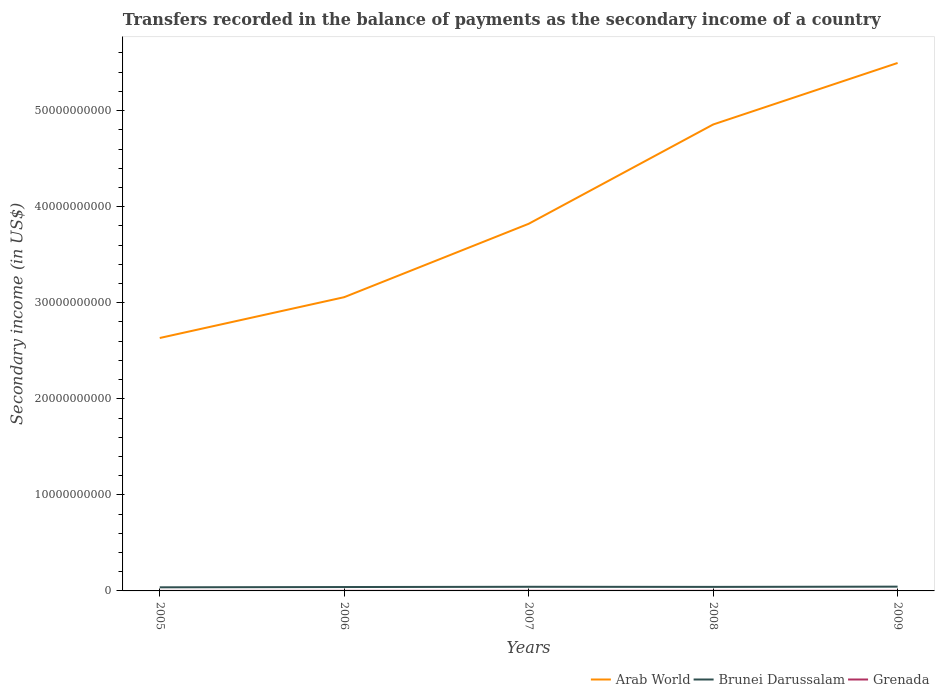How many different coloured lines are there?
Your response must be concise. 3. Is the number of lines equal to the number of legend labels?
Offer a very short reply. Yes. Across all years, what is the maximum secondary income of in Grenada?
Offer a very short reply. 1.42e+06. What is the total secondary income of in Brunei Darussalam in the graph?
Offer a terse response. -6.92e+07. What is the difference between the highest and the second highest secondary income of in Brunei Darussalam?
Provide a short and direct response. 6.92e+07. What is the difference between the highest and the lowest secondary income of in Grenada?
Make the answer very short. 3. How many lines are there?
Make the answer very short. 3. How many legend labels are there?
Give a very brief answer. 3. How are the legend labels stacked?
Ensure brevity in your answer.  Horizontal. What is the title of the graph?
Ensure brevity in your answer.  Transfers recorded in the balance of payments as the secondary income of a country. Does "New Zealand" appear as one of the legend labels in the graph?
Your answer should be very brief. No. What is the label or title of the Y-axis?
Your answer should be very brief. Secondary income (in US$). What is the Secondary income (in US$) in Arab World in 2005?
Offer a very short reply. 2.63e+1. What is the Secondary income (in US$) in Brunei Darussalam in 2005?
Make the answer very short. 3.76e+08. What is the Secondary income (in US$) in Grenada in 2005?
Offer a very short reply. 1.42e+06. What is the Secondary income (in US$) in Arab World in 2006?
Provide a succinct answer. 3.06e+1. What is the Secondary income (in US$) of Brunei Darussalam in 2006?
Make the answer very short. 4.05e+08. What is the Secondary income (in US$) in Grenada in 2006?
Your response must be concise. 8.19e+06. What is the Secondary income (in US$) of Arab World in 2007?
Your answer should be compact. 3.82e+1. What is the Secondary income (in US$) of Brunei Darussalam in 2007?
Offer a terse response. 4.30e+08. What is the Secondary income (in US$) of Grenada in 2007?
Ensure brevity in your answer.  1.13e+07. What is the Secondary income (in US$) of Arab World in 2008?
Give a very brief answer. 4.86e+1. What is the Secondary income (in US$) in Brunei Darussalam in 2008?
Make the answer very short. 4.20e+08. What is the Secondary income (in US$) in Grenada in 2008?
Ensure brevity in your answer.  1.11e+07. What is the Secondary income (in US$) in Arab World in 2009?
Ensure brevity in your answer.  5.50e+1. What is the Secondary income (in US$) in Brunei Darussalam in 2009?
Give a very brief answer. 4.45e+08. What is the Secondary income (in US$) in Grenada in 2009?
Your response must be concise. 1.14e+07. Across all years, what is the maximum Secondary income (in US$) in Arab World?
Provide a succinct answer. 5.50e+1. Across all years, what is the maximum Secondary income (in US$) in Brunei Darussalam?
Offer a very short reply. 4.45e+08. Across all years, what is the maximum Secondary income (in US$) in Grenada?
Your answer should be very brief. 1.14e+07. Across all years, what is the minimum Secondary income (in US$) of Arab World?
Your response must be concise. 2.63e+1. Across all years, what is the minimum Secondary income (in US$) in Brunei Darussalam?
Make the answer very short. 3.76e+08. Across all years, what is the minimum Secondary income (in US$) in Grenada?
Your answer should be very brief. 1.42e+06. What is the total Secondary income (in US$) in Arab World in the graph?
Keep it short and to the point. 1.99e+11. What is the total Secondary income (in US$) of Brunei Darussalam in the graph?
Make the answer very short. 2.08e+09. What is the total Secondary income (in US$) in Grenada in the graph?
Make the answer very short. 4.34e+07. What is the difference between the Secondary income (in US$) of Arab World in 2005 and that in 2006?
Provide a short and direct response. -4.25e+09. What is the difference between the Secondary income (in US$) of Brunei Darussalam in 2005 and that in 2006?
Offer a very short reply. -2.99e+07. What is the difference between the Secondary income (in US$) in Grenada in 2005 and that in 2006?
Give a very brief answer. -6.77e+06. What is the difference between the Secondary income (in US$) in Arab World in 2005 and that in 2007?
Provide a succinct answer. -1.19e+1. What is the difference between the Secondary income (in US$) of Brunei Darussalam in 2005 and that in 2007?
Offer a terse response. -5.47e+07. What is the difference between the Secondary income (in US$) in Grenada in 2005 and that in 2007?
Make the answer very short. -9.89e+06. What is the difference between the Secondary income (in US$) in Arab World in 2005 and that in 2008?
Your answer should be very brief. -2.22e+1. What is the difference between the Secondary income (in US$) of Brunei Darussalam in 2005 and that in 2008?
Make the answer very short. -4.48e+07. What is the difference between the Secondary income (in US$) in Grenada in 2005 and that in 2008?
Offer a terse response. -9.63e+06. What is the difference between the Secondary income (in US$) in Arab World in 2005 and that in 2009?
Offer a very short reply. -2.86e+1. What is the difference between the Secondary income (in US$) of Brunei Darussalam in 2005 and that in 2009?
Provide a succinct answer. -6.92e+07. What is the difference between the Secondary income (in US$) of Grenada in 2005 and that in 2009?
Offer a terse response. -1.00e+07. What is the difference between the Secondary income (in US$) of Arab World in 2006 and that in 2007?
Keep it short and to the point. -7.64e+09. What is the difference between the Secondary income (in US$) in Brunei Darussalam in 2006 and that in 2007?
Offer a terse response. -2.48e+07. What is the difference between the Secondary income (in US$) in Grenada in 2006 and that in 2007?
Make the answer very short. -3.13e+06. What is the difference between the Secondary income (in US$) of Arab World in 2006 and that in 2008?
Offer a very short reply. -1.80e+1. What is the difference between the Secondary income (in US$) of Brunei Darussalam in 2006 and that in 2008?
Keep it short and to the point. -1.49e+07. What is the difference between the Secondary income (in US$) of Grenada in 2006 and that in 2008?
Give a very brief answer. -2.86e+06. What is the difference between the Secondary income (in US$) in Arab World in 2006 and that in 2009?
Provide a short and direct response. -2.44e+1. What is the difference between the Secondary income (in US$) of Brunei Darussalam in 2006 and that in 2009?
Your answer should be very brief. -3.94e+07. What is the difference between the Secondary income (in US$) in Grenada in 2006 and that in 2009?
Provide a short and direct response. -3.25e+06. What is the difference between the Secondary income (in US$) in Arab World in 2007 and that in 2008?
Make the answer very short. -1.03e+1. What is the difference between the Secondary income (in US$) of Brunei Darussalam in 2007 and that in 2008?
Offer a terse response. 9.93e+06. What is the difference between the Secondary income (in US$) of Grenada in 2007 and that in 2008?
Make the answer very short. 2.65e+05. What is the difference between the Secondary income (in US$) of Arab World in 2007 and that in 2009?
Offer a very short reply. -1.67e+1. What is the difference between the Secondary income (in US$) of Brunei Darussalam in 2007 and that in 2009?
Provide a succinct answer. -1.45e+07. What is the difference between the Secondary income (in US$) of Grenada in 2007 and that in 2009?
Offer a terse response. -1.26e+05. What is the difference between the Secondary income (in US$) in Arab World in 2008 and that in 2009?
Give a very brief answer. -6.40e+09. What is the difference between the Secondary income (in US$) in Brunei Darussalam in 2008 and that in 2009?
Give a very brief answer. -2.45e+07. What is the difference between the Secondary income (in US$) of Grenada in 2008 and that in 2009?
Ensure brevity in your answer.  -3.91e+05. What is the difference between the Secondary income (in US$) in Arab World in 2005 and the Secondary income (in US$) in Brunei Darussalam in 2006?
Keep it short and to the point. 2.59e+1. What is the difference between the Secondary income (in US$) of Arab World in 2005 and the Secondary income (in US$) of Grenada in 2006?
Make the answer very short. 2.63e+1. What is the difference between the Secondary income (in US$) of Brunei Darussalam in 2005 and the Secondary income (in US$) of Grenada in 2006?
Offer a terse response. 3.67e+08. What is the difference between the Secondary income (in US$) of Arab World in 2005 and the Secondary income (in US$) of Brunei Darussalam in 2007?
Your response must be concise. 2.59e+1. What is the difference between the Secondary income (in US$) in Arab World in 2005 and the Secondary income (in US$) in Grenada in 2007?
Provide a short and direct response. 2.63e+1. What is the difference between the Secondary income (in US$) in Brunei Darussalam in 2005 and the Secondary income (in US$) in Grenada in 2007?
Give a very brief answer. 3.64e+08. What is the difference between the Secondary income (in US$) of Arab World in 2005 and the Secondary income (in US$) of Brunei Darussalam in 2008?
Your response must be concise. 2.59e+1. What is the difference between the Secondary income (in US$) of Arab World in 2005 and the Secondary income (in US$) of Grenada in 2008?
Your response must be concise. 2.63e+1. What is the difference between the Secondary income (in US$) in Brunei Darussalam in 2005 and the Secondary income (in US$) in Grenada in 2008?
Keep it short and to the point. 3.65e+08. What is the difference between the Secondary income (in US$) of Arab World in 2005 and the Secondary income (in US$) of Brunei Darussalam in 2009?
Provide a short and direct response. 2.59e+1. What is the difference between the Secondary income (in US$) in Arab World in 2005 and the Secondary income (in US$) in Grenada in 2009?
Offer a very short reply. 2.63e+1. What is the difference between the Secondary income (in US$) in Brunei Darussalam in 2005 and the Secondary income (in US$) in Grenada in 2009?
Your answer should be compact. 3.64e+08. What is the difference between the Secondary income (in US$) of Arab World in 2006 and the Secondary income (in US$) of Brunei Darussalam in 2007?
Make the answer very short. 3.01e+1. What is the difference between the Secondary income (in US$) of Arab World in 2006 and the Secondary income (in US$) of Grenada in 2007?
Offer a very short reply. 3.06e+1. What is the difference between the Secondary income (in US$) of Brunei Darussalam in 2006 and the Secondary income (in US$) of Grenada in 2007?
Make the answer very short. 3.94e+08. What is the difference between the Secondary income (in US$) in Arab World in 2006 and the Secondary income (in US$) in Brunei Darussalam in 2008?
Your response must be concise. 3.02e+1. What is the difference between the Secondary income (in US$) in Arab World in 2006 and the Secondary income (in US$) in Grenada in 2008?
Ensure brevity in your answer.  3.06e+1. What is the difference between the Secondary income (in US$) of Brunei Darussalam in 2006 and the Secondary income (in US$) of Grenada in 2008?
Your answer should be very brief. 3.94e+08. What is the difference between the Secondary income (in US$) of Arab World in 2006 and the Secondary income (in US$) of Brunei Darussalam in 2009?
Offer a terse response. 3.01e+1. What is the difference between the Secondary income (in US$) in Arab World in 2006 and the Secondary income (in US$) in Grenada in 2009?
Give a very brief answer. 3.06e+1. What is the difference between the Secondary income (in US$) in Brunei Darussalam in 2006 and the Secondary income (in US$) in Grenada in 2009?
Keep it short and to the point. 3.94e+08. What is the difference between the Secondary income (in US$) of Arab World in 2007 and the Secondary income (in US$) of Brunei Darussalam in 2008?
Give a very brief answer. 3.78e+1. What is the difference between the Secondary income (in US$) of Arab World in 2007 and the Secondary income (in US$) of Grenada in 2008?
Keep it short and to the point. 3.82e+1. What is the difference between the Secondary income (in US$) of Brunei Darussalam in 2007 and the Secondary income (in US$) of Grenada in 2008?
Your answer should be very brief. 4.19e+08. What is the difference between the Secondary income (in US$) of Arab World in 2007 and the Secondary income (in US$) of Brunei Darussalam in 2009?
Make the answer very short. 3.78e+1. What is the difference between the Secondary income (in US$) of Arab World in 2007 and the Secondary income (in US$) of Grenada in 2009?
Ensure brevity in your answer.  3.82e+1. What is the difference between the Secondary income (in US$) of Brunei Darussalam in 2007 and the Secondary income (in US$) of Grenada in 2009?
Your answer should be very brief. 4.19e+08. What is the difference between the Secondary income (in US$) of Arab World in 2008 and the Secondary income (in US$) of Brunei Darussalam in 2009?
Your answer should be very brief. 4.81e+1. What is the difference between the Secondary income (in US$) of Arab World in 2008 and the Secondary income (in US$) of Grenada in 2009?
Make the answer very short. 4.85e+1. What is the difference between the Secondary income (in US$) in Brunei Darussalam in 2008 and the Secondary income (in US$) in Grenada in 2009?
Ensure brevity in your answer.  4.09e+08. What is the average Secondary income (in US$) in Arab World per year?
Provide a succinct answer. 3.97e+1. What is the average Secondary income (in US$) in Brunei Darussalam per year?
Your response must be concise. 4.15e+08. What is the average Secondary income (in US$) in Grenada per year?
Your answer should be compact. 8.69e+06. In the year 2005, what is the difference between the Secondary income (in US$) of Arab World and Secondary income (in US$) of Brunei Darussalam?
Make the answer very short. 2.60e+1. In the year 2005, what is the difference between the Secondary income (in US$) of Arab World and Secondary income (in US$) of Grenada?
Your response must be concise. 2.63e+1. In the year 2005, what is the difference between the Secondary income (in US$) in Brunei Darussalam and Secondary income (in US$) in Grenada?
Make the answer very short. 3.74e+08. In the year 2006, what is the difference between the Secondary income (in US$) of Arab World and Secondary income (in US$) of Brunei Darussalam?
Your answer should be compact. 3.02e+1. In the year 2006, what is the difference between the Secondary income (in US$) of Arab World and Secondary income (in US$) of Grenada?
Your response must be concise. 3.06e+1. In the year 2006, what is the difference between the Secondary income (in US$) in Brunei Darussalam and Secondary income (in US$) in Grenada?
Your answer should be very brief. 3.97e+08. In the year 2007, what is the difference between the Secondary income (in US$) of Arab World and Secondary income (in US$) of Brunei Darussalam?
Offer a very short reply. 3.78e+1. In the year 2007, what is the difference between the Secondary income (in US$) in Arab World and Secondary income (in US$) in Grenada?
Offer a very short reply. 3.82e+1. In the year 2007, what is the difference between the Secondary income (in US$) of Brunei Darussalam and Secondary income (in US$) of Grenada?
Make the answer very short. 4.19e+08. In the year 2008, what is the difference between the Secondary income (in US$) in Arab World and Secondary income (in US$) in Brunei Darussalam?
Your answer should be compact. 4.81e+1. In the year 2008, what is the difference between the Secondary income (in US$) of Arab World and Secondary income (in US$) of Grenada?
Give a very brief answer. 4.85e+1. In the year 2008, what is the difference between the Secondary income (in US$) in Brunei Darussalam and Secondary income (in US$) in Grenada?
Your response must be concise. 4.09e+08. In the year 2009, what is the difference between the Secondary income (in US$) of Arab World and Secondary income (in US$) of Brunei Darussalam?
Your answer should be very brief. 5.45e+1. In the year 2009, what is the difference between the Secondary income (in US$) in Arab World and Secondary income (in US$) in Grenada?
Give a very brief answer. 5.49e+1. In the year 2009, what is the difference between the Secondary income (in US$) in Brunei Darussalam and Secondary income (in US$) in Grenada?
Keep it short and to the point. 4.33e+08. What is the ratio of the Secondary income (in US$) in Arab World in 2005 to that in 2006?
Give a very brief answer. 0.86. What is the ratio of the Secondary income (in US$) of Brunei Darussalam in 2005 to that in 2006?
Ensure brevity in your answer.  0.93. What is the ratio of the Secondary income (in US$) in Grenada in 2005 to that in 2006?
Offer a terse response. 0.17. What is the ratio of the Secondary income (in US$) of Arab World in 2005 to that in 2007?
Keep it short and to the point. 0.69. What is the ratio of the Secondary income (in US$) in Brunei Darussalam in 2005 to that in 2007?
Keep it short and to the point. 0.87. What is the ratio of the Secondary income (in US$) of Grenada in 2005 to that in 2007?
Provide a succinct answer. 0.13. What is the ratio of the Secondary income (in US$) of Arab World in 2005 to that in 2008?
Provide a succinct answer. 0.54. What is the ratio of the Secondary income (in US$) of Brunei Darussalam in 2005 to that in 2008?
Offer a very short reply. 0.89. What is the ratio of the Secondary income (in US$) in Grenada in 2005 to that in 2008?
Offer a very short reply. 0.13. What is the ratio of the Secondary income (in US$) of Arab World in 2005 to that in 2009?
Offer a very short reply. 0.48. What is the ratio of the Secondary income (in US$) of Brunei Darussalam in 2005 to that in 2009?
Give a very brief answer. 0.84. What is the ratio of the Secondary income (in US$) of Grenada in 2005 to that in 2009?
Provide a succinct answer. 0.12. What is the ratio of the Secondary income (in US$) in Arab World in 2006 to that in 2007?
Ensure brevity in your answer.  0.8. What is the ratio of the Secondary income (in US$) of Brunei Darussalam in 2006 to that in 2007?
Ensure brevity in your answer.  0.94. What is the ratio of the Secondary income (in US$) of Grenada in 2006 to that in 2007?
Keep it short and to the point. 0.72. What is the ratio of the Secondary income (in US$) in Arab World in 2006 to that in 2008?
Make the answer very short. 0.63. What is the ratio of the Secondary income (in US$) of Brunei Darussalam in 2006 to that in 2008?
Provide a succinct answer. 0.96. What is the ratio of the Secondary income (in US$) of Grenada in 2006 to that in 2008?
Offer a very short reply. 0.74. What is the ratio of the Secondary income (in US$) in Arab World in 2006 to that in 2009?
Keep it short and to the point. 0.56. What is the ratio of the Secondary income (in US$) in Brunei Darussalam in 2006 to that in 2009?
Give a very brief answer. 0.91. What is the ratio of the Secondary income (in US$) of Grenada in 2006 to that in 2009?
Your answer should be compact. 0.72. What is the ratio of the Secondary income (in US$) of Arab World in 2007 to that in 2008?
Provide a succinct answer. 0.79. What is the ratio of the Secondary income (in US$) in Brunei Darussalam in 2007 to that in 2008?
Your answer should be compact. 1.02. What is the ratio of the Secondary income (in US$) in Arab World in 2007 to that in 2009?
Your response must be concise. 0.7. What is the ratio of the Secondary income (in US$) in Brunei Darussalam in 2007 to that in 2009?
Offer a very short reply. 0.97. What is the ratio of the Secondary income (in US$) of Arab World in 2008 to that in 2009?
Provide a short and direct response. 0.88. What is the ratio of the Secondary income (in US$) in Brunei Darussalam in 2008 to that in 2009?
Your answer should be compact. 0.94. What is the ratio of the Secondary income (in US$) in Grenada in 2008 to that in 2009?
Your answer should be compact. 0.97. What is the difference between the highest and the second highest Secondary income (in US$) in Arab World?
Offer a terse response. 6.40e+09. What is the difference between the highest and the second highest Secondary income (in US$) in Brunei Darussalam?
Ensure brevity in your answer.  1.45e+07. What is the difference between the highest and the second highest Secondary income (in US$) of Grenada?
Offer a terse response. 1.26e+05. What is the difference between the highest and the lowest Secondary income (in US$) of Arab World?
Your answer should be compact. 2.86e+1. What is the difference between the highest and the lowest Secondary income (in US$) of Brunei Darussalam?
Offer a terse response. 6.92e+07. What is the difference between the highest and the lowest Secondary income (in US$) in Grenada?
Keep it short and to the point. 1.00e+07. 